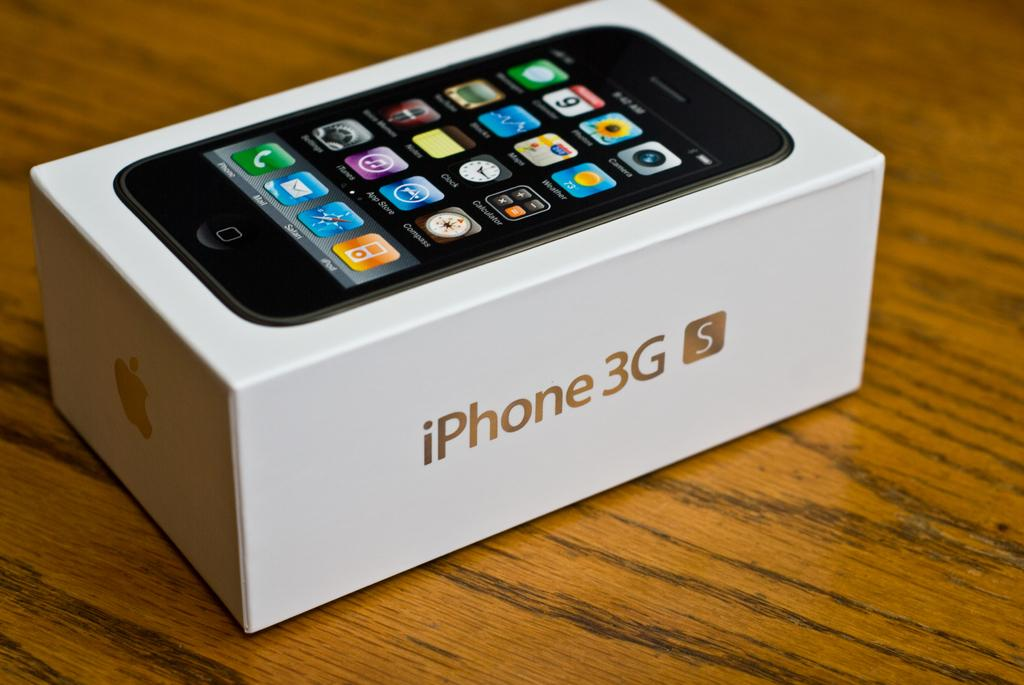<image>
Offer a succinct explanation of the picture presented. an iPhone box that is on the brown table 